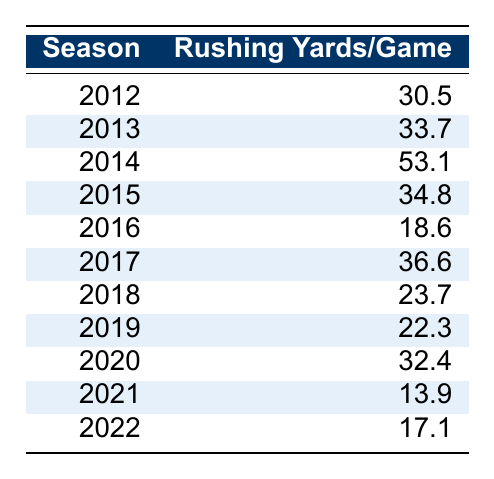What was Russell Wilson's rushing yards per game in 2014? From the table, in the season 2014, the rushing yards per game listed is 53.1.
Answer: 53.1 What was the average rushing yards per game over the seasons 2012 to 2016? To calculate the average, first find the sum of the rushing yards per game for those seasons: (30.5 + 33.7 + 53.1 + 34.8 + 18.6) = 170.7. Then divide by the number of seasons, which is 5, giving 170.7 / 5 = 34.14.
Answer: 34.14 In which season did Russell Wilson have the lowest rushing yards per game? By examining the table, the season with the lowest rushing yards per game is 2021, where he had 13.9 yards.
Answer: 2021 How much did Russell Wilson's rushing yards per game decrease from 2014 to 2016? In 2014, he had 53.1 rushing yards per game, and in 2016 it was 18.6. The difference is 53.1 - 18.6 = 34.5.
Answer: 34.5 Was Russell Wilson's rushing performance better in 2013 compared to 2015? In 2013, he had 33.7 rushing yards per game, while in 2015 he had 34.8. Since 34.8 > 33.7, his performance was indeed better in 2015.
Answer: Yes What is the total rushing yards per game for the years 2017 and 2019? Adding the rushing yards per game from 2017 (36.6) and 2019 (22.3) gives us 36.6 + 22.3 = 58.9.
Answer: 58.9 How many seasons did Russell Wilson average over 30 rushing yards per game? By reviewing the values, the seasons with over 30 rushing yards per game are 2012 (30.5), 2013 (33.7), 2014 (53.1), 2015 (34.8), and 2020 (32.4)—a total of 5 seasons.
Answer: 5 What was the year-on-year change in rushing yards per game from 2017 to 2018? In 2017, the rushing yards per game were 36.6 and in 2018 it was 23.7. The change is 23.7 - 36.6 = -12.9, indicating a decrease.
Answer: -12.9 Which season had the most significant increase in rushing yards per game compared to the previous season? Comparing the differences: from 2012 to 2013 (+3.2), from 2013 to 2014 (+19.4), from 2014 to 2015 (-18.3), and so on, the largest increase is from 2013 to 2014, which is +19.4.
Answer: 2014 Did Russell Wilson's rushing yards per game decline consistently every season after 2015? Reviewing the table, after 2015 (34.8), it did not decline consistently: it dropped to 18.6 in 2016, rose to 36.6 in 2017, and then dipped again, indicating fluctuations rather than a consistent decline.
Answer: No 